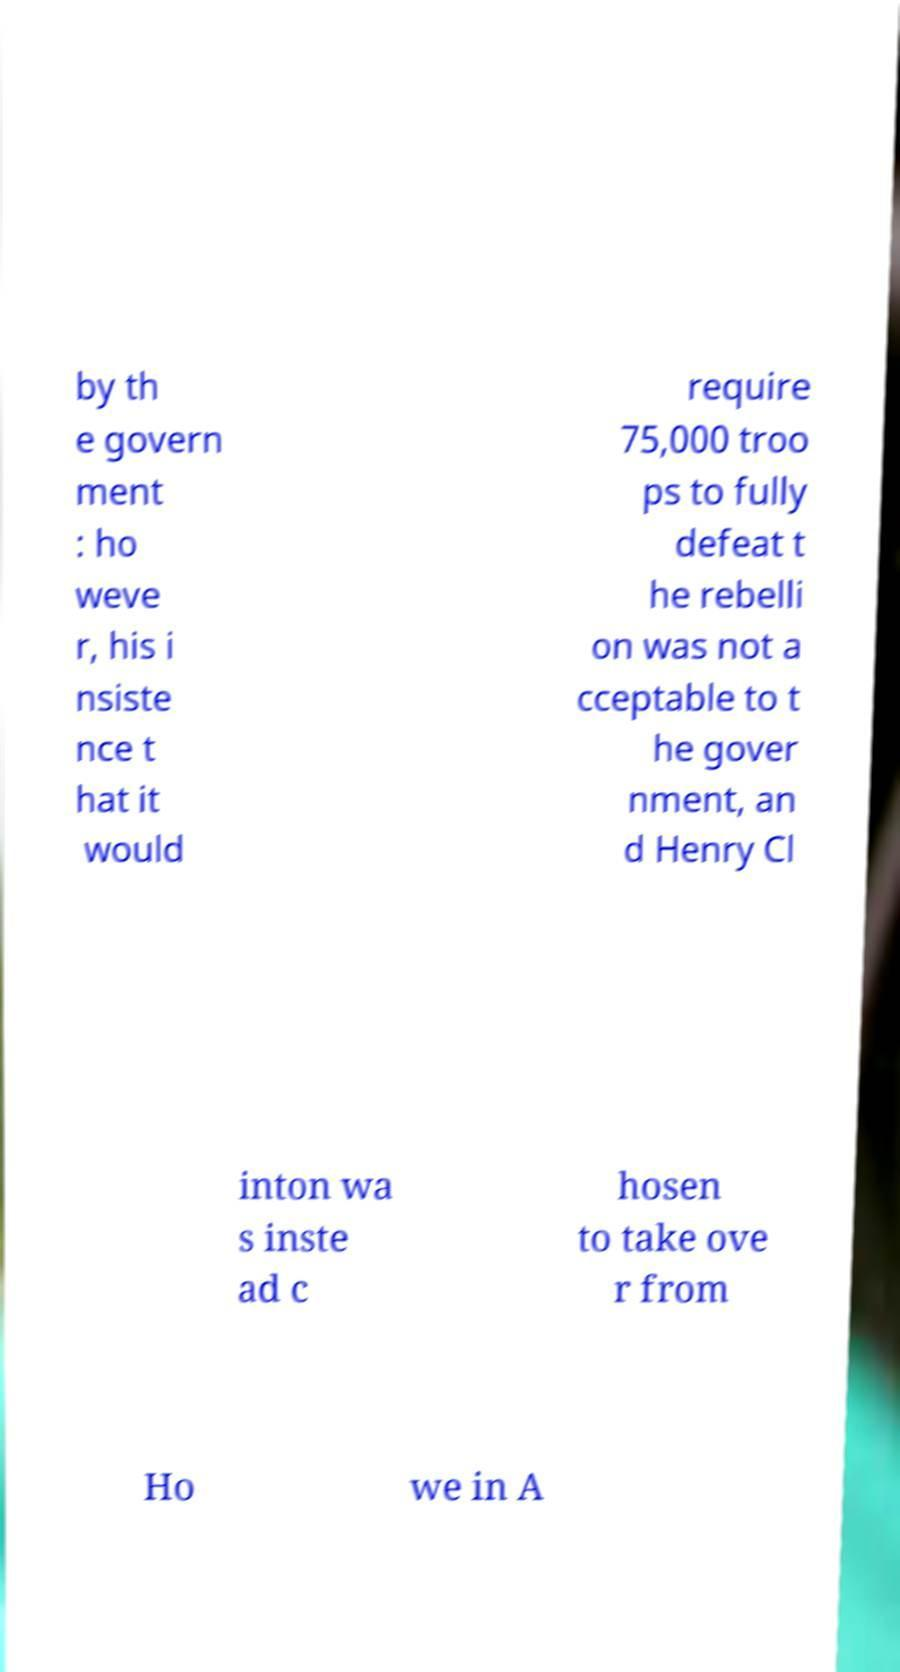For documentation purposes, I need the text within this image transcribed. Could you provide that? by th e govern ment : ho weve r, his i nsiste nce t hat it would require 75,000 troo ps to fully defeat t he rebelli on was not a cceptable to t he gover nment, an d Henry Cl inton wa s inste ad c hosen to take ove r from Ho we in A 